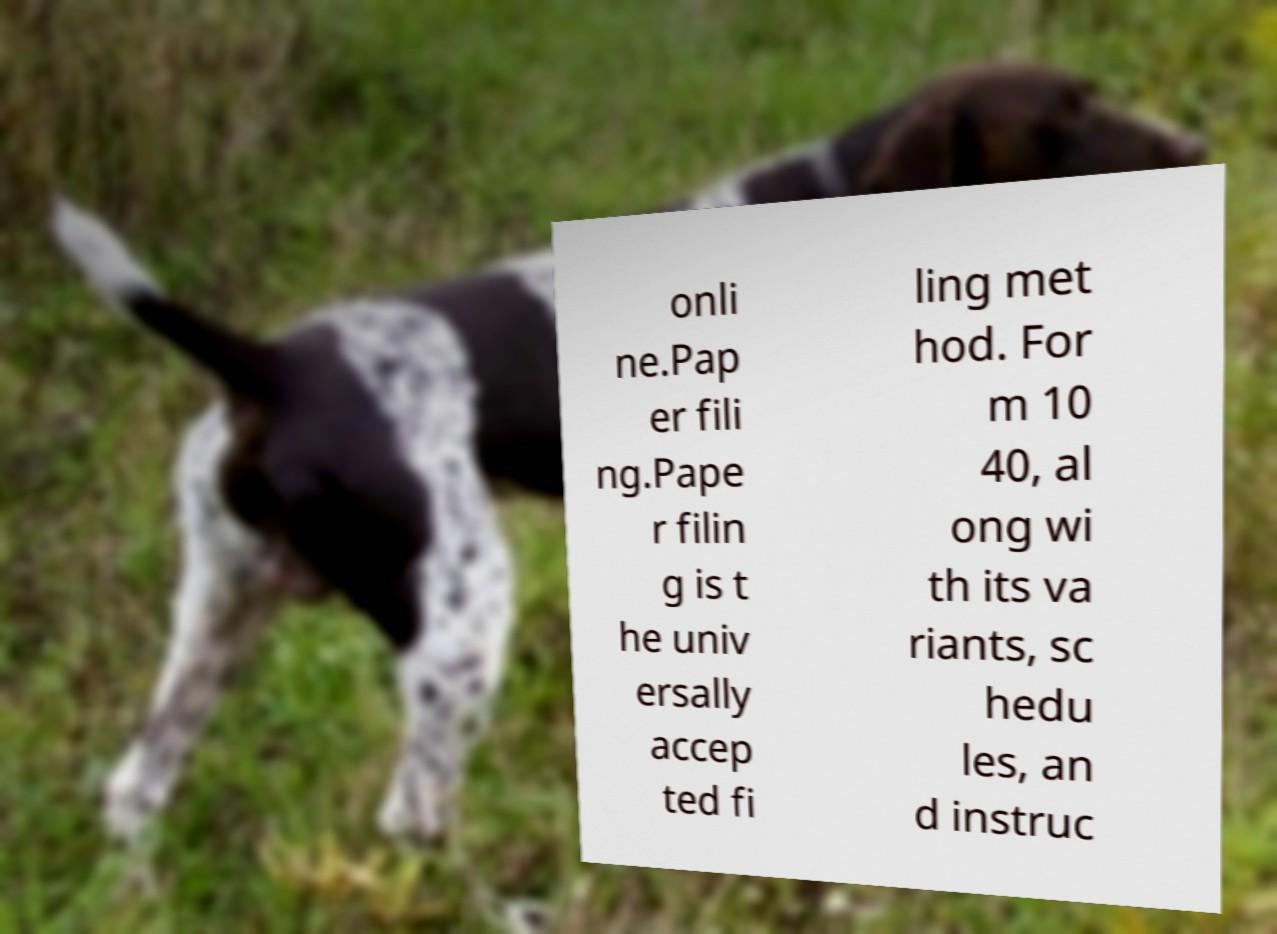I need the written content from this picture converted into text. Can you do that? onli ne.Pap er fili ng.Pape r filin g is t he univ ersally accep ted fi ling met hod. For m 10 40, al ong wi th its va riants, sc hedu les, an d instruc 